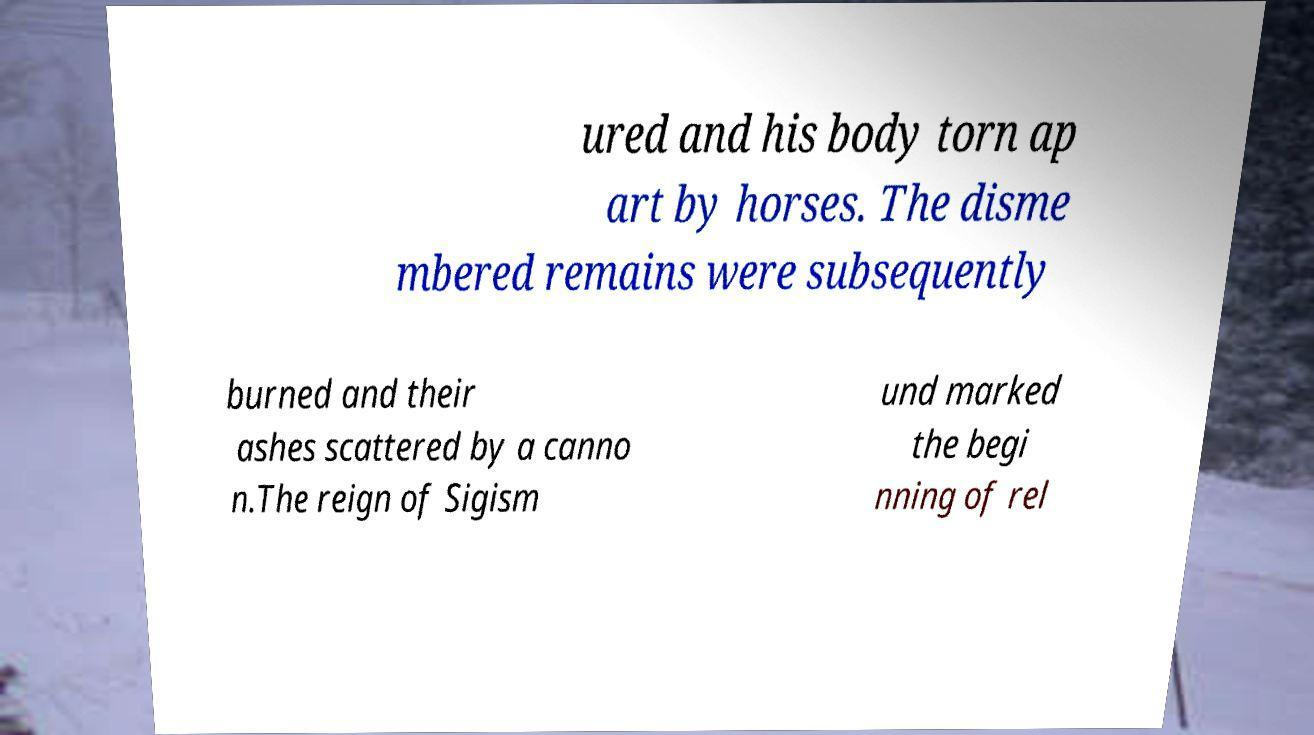There's text embedded in this image that I need extracted. Can you transcribe it verbatim? ured and his body torn ap art by horses. The disme mbered remains were subsequently burned and their ashes scattered by a canno n.The reign of Sigism und marked the begi nning of rel 